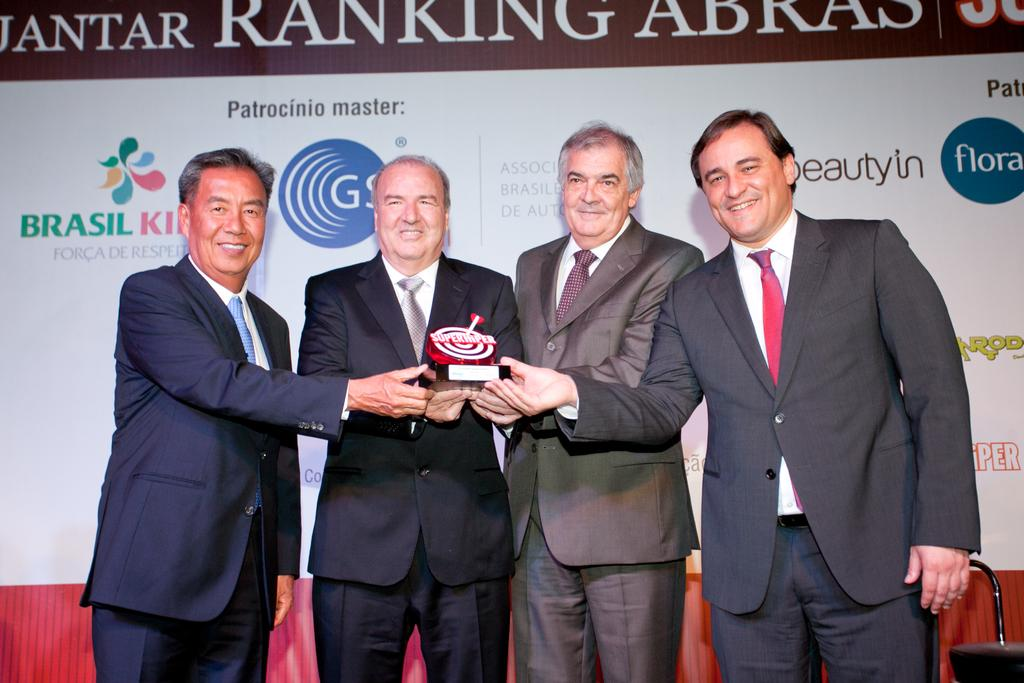How many people are present in the image? There are four persons in the image. What are the persons holding in the image? The persons are holding an object. Can you describe any additional elements in the image? There is a board with text in the image. What type of ball can be seen rolling on the ground in the image? There is no ball present in the image; the persons are holding an object, and there is a board with text. Is the scene taking place during the night in the image? The facts provided do not mention the time of day, so we cannot determine if it is night or not. 